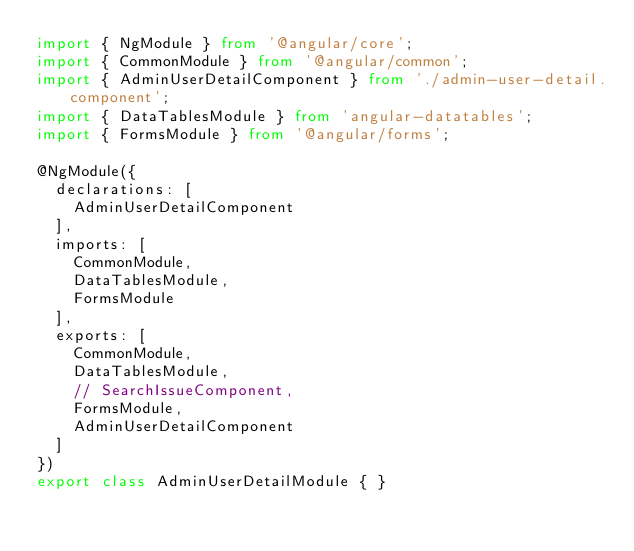Convert code to text. <code><loc_0><loc_0><loc_500><loc_500><_TypeScript_>import { NgModule } from '@angular/core';
import { CommonModule } from '@angular/common';
import { AdminUserDetailComponent } from './admin-user-detail.component';
import { DataTablesModule } from 'angular-datatables';
import { FormsModule } from '@angular/forms';

@NgModule({
  declarations: [
    AdminUserDetailComponent
  ],
  imports: [
    CommonModule,
    DataTablesModule,
    FormsModule
  ],
  exports: [
    CommonModule,
    DataTablesModule,
    // SearchIssueComponent,
    FormsModule,
    AdminUserDetailComponent
  ]
})
export class AdminUserDetailModule { }
</code> 